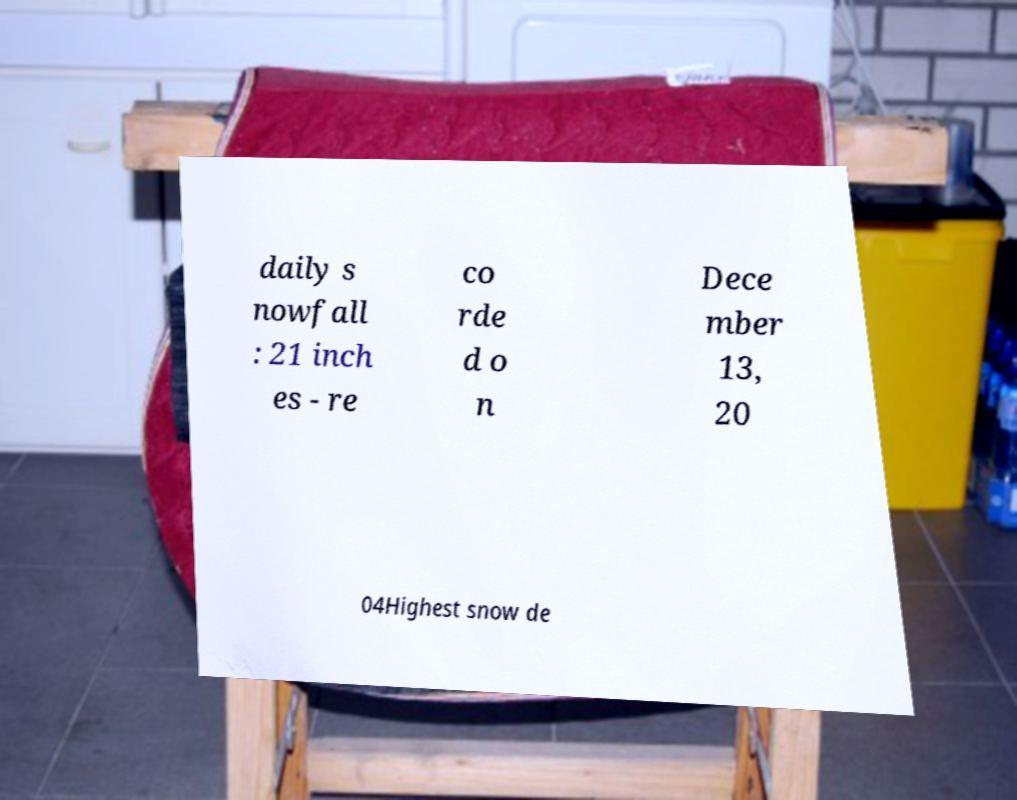Please read and relay the text visible in this image. What does it say? daily s nowfall : 21 inch es - re co rde d o n Dece mber 13, 20 04Highest snow de 